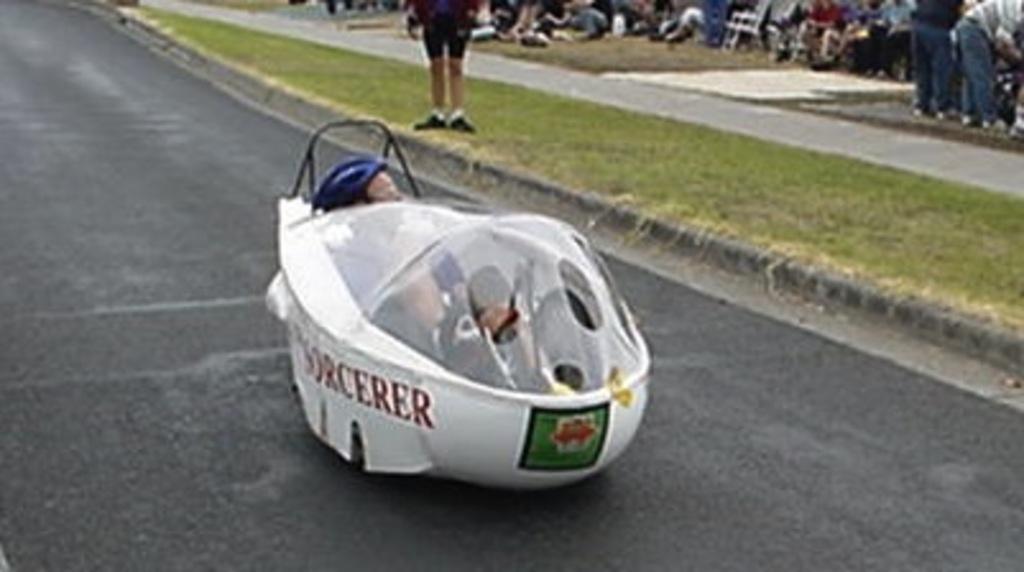How would you summarize this image in a sentence or two? In the center of the image we can see a racing car. In the background there are people. At the bottom there is a road. 